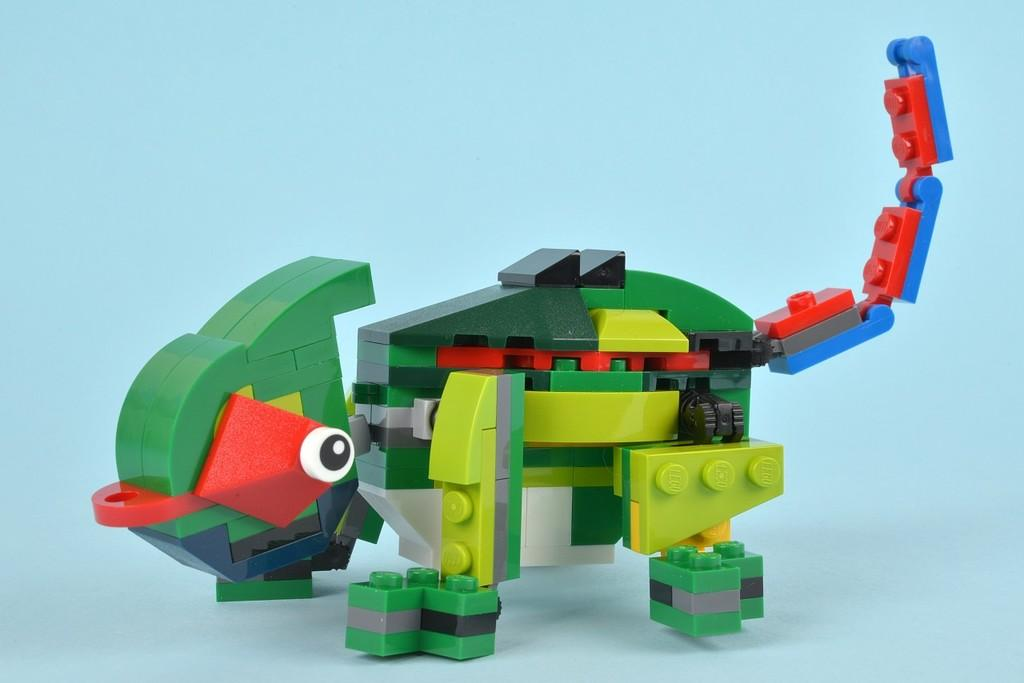How many toes can be seen on the hydrant in the image? There is no hydrant present in the image, and therefore no toes can be observed on it. What type of crook is being used by the person in the image? There is no person or crook present in the image. 